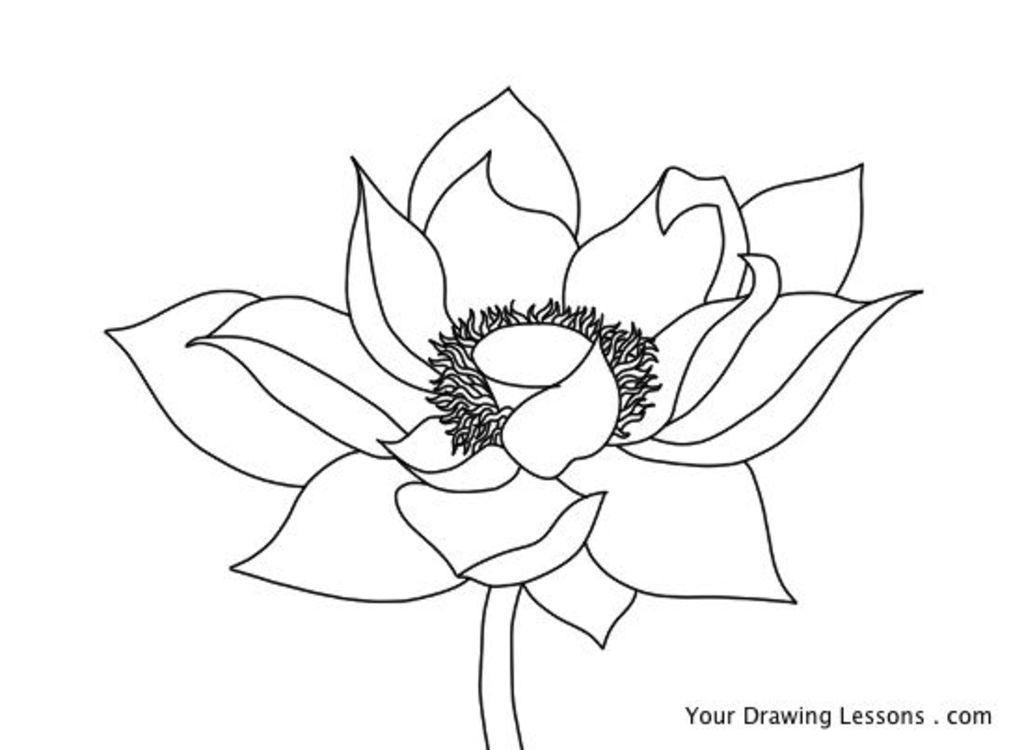What is the main subject of the image? The main subject of the image is a drawing of a flower. What else can be seen in the image besides the flower? There is text written on the image. How many pigs are present in the image? There are no pigs present in the image; it features a drawing of a flower and text. What type of material is the flower made of in the image? The image is a drawing, so the flower is made of lines and colors on a surface, not a physical material like marble. 